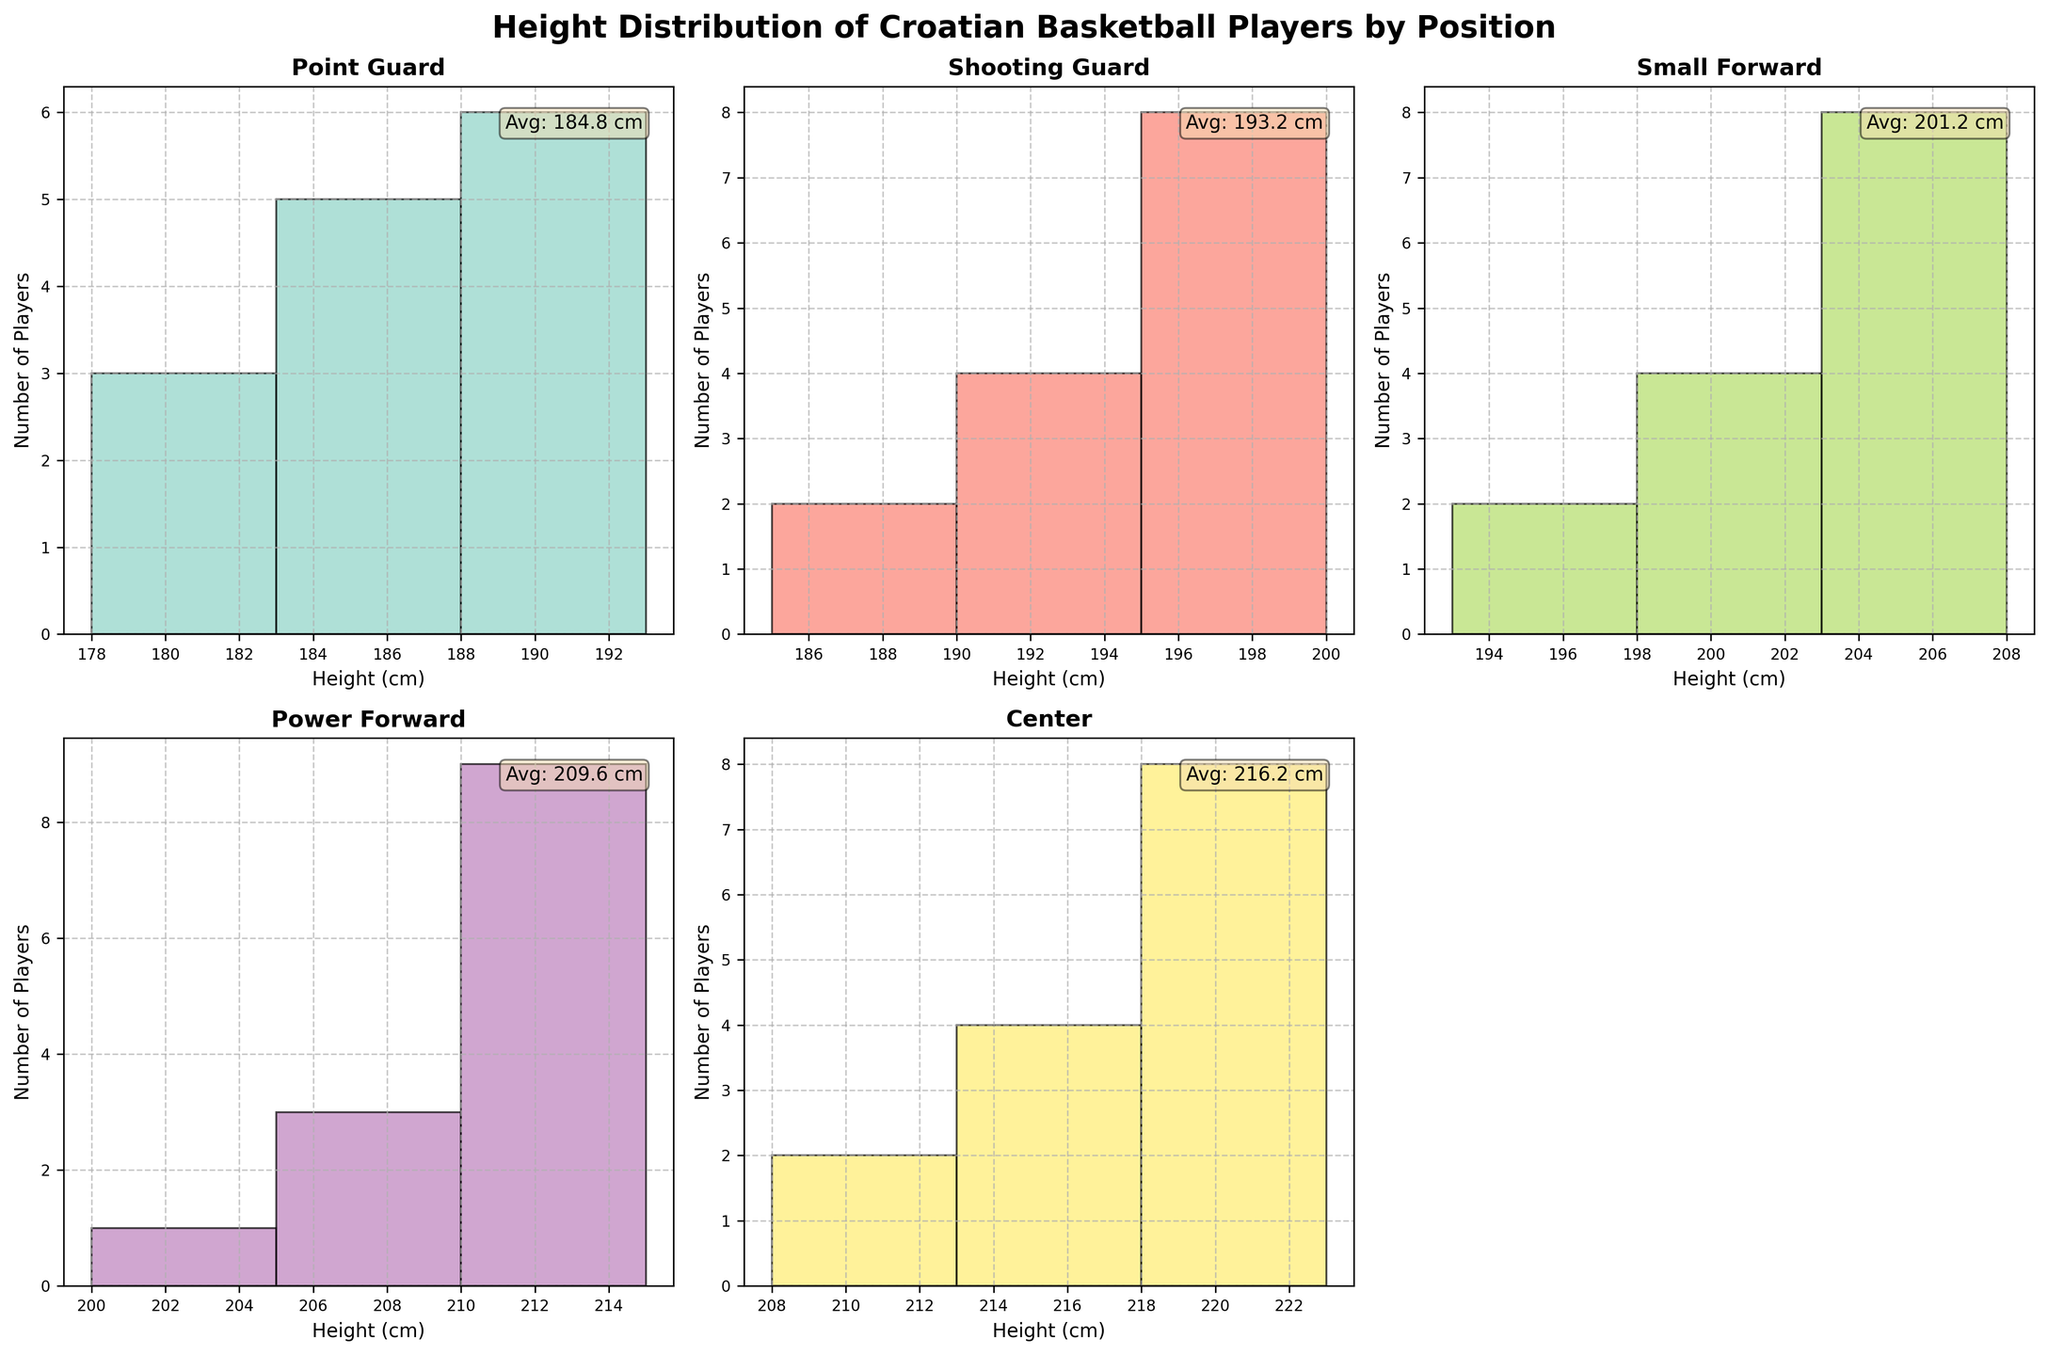What's the title of the figure? The title is usually at the top of the figure and provides a summary of what the figure represents. Here, the title is "Height Distribution of Croatian Basketball Players by Position".
Answer: Height Distribution of Croatian Basketball Players by Position Which position has the tallest average height? To determine the tallest average height, we need to look inside each subplot. We'll use the average height values noted in each text box. The tallest average given in the subplots is for the "Center" position.
Answer: Center Which position shows the most diverse range of player heights? To find the most diverse range of player heights, we need to look for the position with the widest spread in the histogram. The Center position spreads from 208 cm to 223 cm, which is greater than the spread in other positions.
Answer: Center How many players are Point Guards with a height of 183 cm? In the Point Guard histogram, we check the bar corresponding to the height of 183 cm. The y-axis value of this bar is 5, indicating there are 5 players of that height.
Answer: 5 What is the range of heights for Small Forwards? In the Small Forward histogram, the heights range from the smallest to the largest value shown by the bars. The smallest height is 193 cm and the largest height is 208 cm. Therefore, the range is 193 cm to 208 cm.
Answer: 193 cm to 208 cm Which position has the least player count in any height group, and what is that count? By looking at the height and player count of each bar in each subplot, the minimum count is given by the very few bars that reach only 1 in the Power Forward histogram for 200 cm.
Answer: Power Forward; 1 What is the average height for players at the Point Guard position? The average height is explicitly given in the text box within the subplot for Point Guards. Here, the value is written as "Avg: 185.7 cm." Hence, the average height is 185.7 cm.
Answer: 185.7 cm Which two positions have the closest average heights? From the average height values in the text boxes for each subplot, we identify which two values are closest. Shooting Guards have an average of 194.2 cm, and Power Forwards have an average of 210 cm. Hence, the two closest are Shooting Guards (194.2 cm) and Small Forwards (200.0 cm).
Answer: Shooting Guard and Small Forward In which height category do Centers have the most players? For Centers, we look at their histogram and find the tallest bar, then identify its corresponding height range. The highest frequency bar is for the 218 cm category with 5 players.
Answer: 218 cm 